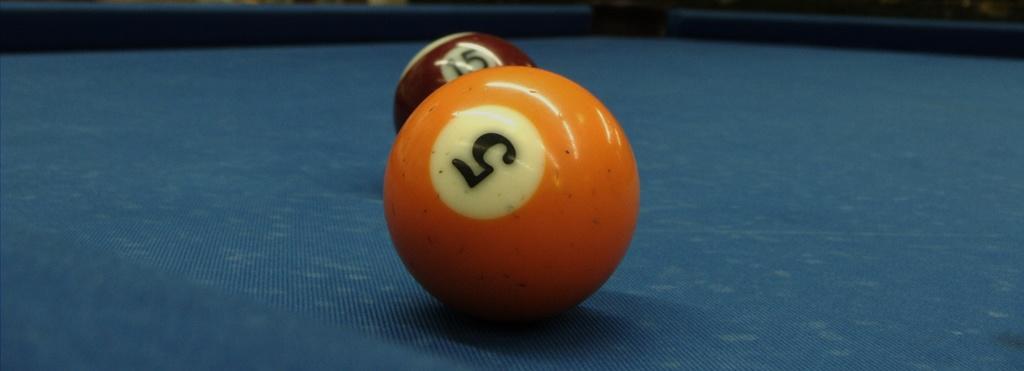Can you describe this image briefly? In this picture we can see two balls on a pool table. 